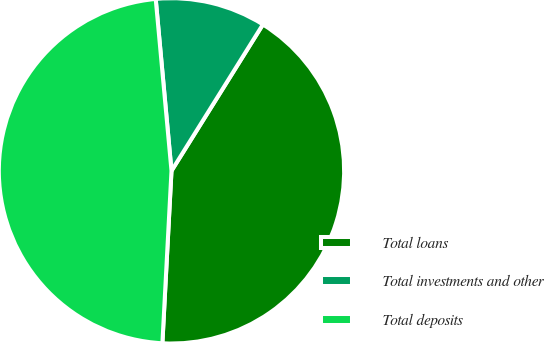Convert chart to OTSL. <chart><loc_0><loc_0><loc_500><loc_500><pie_chart><fcel>Total loans<fcel>Total investments and other<fcel>Total deposits<nl><fcel>41.95%<fcel>10.34%<fcel>47.7%<nl></chart> 